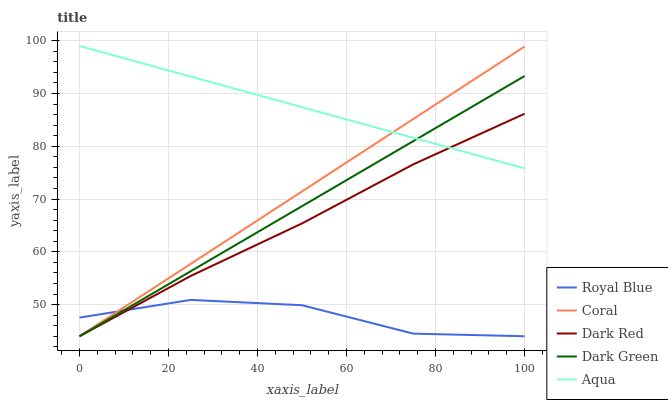Does Coral have the minimum area under the curve?
Answer yes or no. No. Does Coral have the maximum area under the curve?
Answer yes or no. No. Is Aqua the smoothest?
Answer yes or no. No. Is Aqua the roughest?
Answer yes or no. No. Does Aqua have the lowest value?
Answer yes or no. No. Does Coral have the highest value?
Answer yes or no. No. Is Royal Blue less than Aqua?
Answer yes or no. Yes. Is Aqua greater than Royal Blue?
Answer yes or no. Yes. Does Royal Blue intersect Aqua?
Answer yes or no. No. 